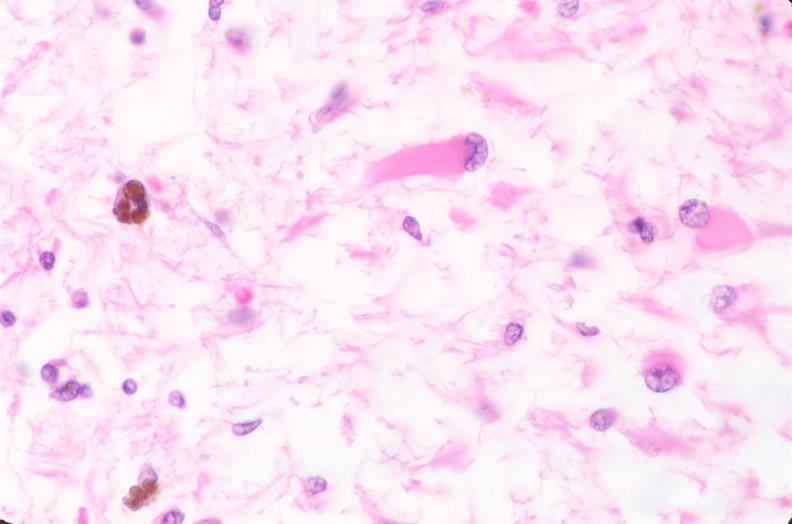what does this image show?
Answer the question using a single word or phrase. Brain 